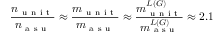Convert formula to latex. <formula><loc_0><loc_0><loc_500><loc_500>\frac { n _ { u n i t } } { n _ { a s u } } \approx \frac { m _ { u n i t } } { m _ { a s u } } \approx \frac { m _ { u n i t } ^ { L ( G ) } } { m _ { a s u } ^ { L ( G ) } } \approx 2 . 1</formula> 